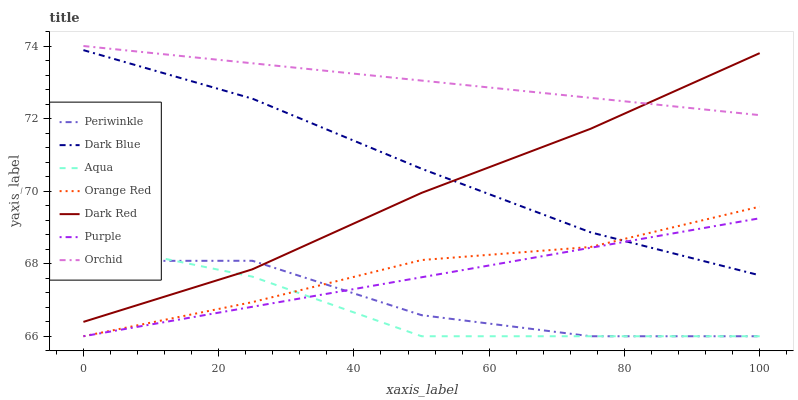Does Aqua have the minimum area under the curve?
Answer yes or no. Yes. Does Orchid have the maximum area under the curve?
Answer yes or no. Yes. Does Dark Red have the minimum area under the curve?
Answer yes or no. No. Does Dark Red have the maximum area under the curve?
Answer yes or no. No. Is Orchid the smoothest?
Answer yes or no. Yes. Is Periwinkle the roughest?
Answer yes or no. Yes. Is Dark Red the smoothest?
Answer yes or no. No. Is Dark Red the roughest?
Answer yes or no. No. Does Dark Red have the lowest value?
Answer yes or no. No. Does Orchid have the highest value?
Answer yes or no. Yes. Does Dark Red have the highest value?
Answer yes or no. No. Is Aqua less than Dark Blue?
Answer yes or no. Yes. Is Dark Blue greater than Aqua?
Answer yes or no. Yes. Does Dark Blue intersect Orange Red?
Answer yes or no. Yes. Is Dark Blue less than Orange Red?
Answer yes or no. No. Is Dark Blue greater than Orange Red?
Answer yes or no. No. Does Aqua intersect Dark Blue?
Answer yes or no. No. 